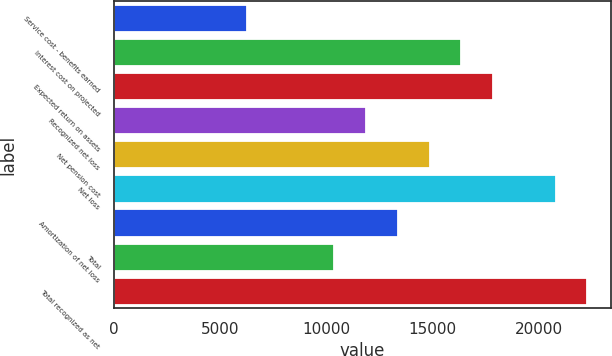<chart> <loc_0><loc_0><loc_500><loc_500><bar_chart><fcel>Service cost - benefits earned<fcel>Interest cost on projected<fcel>Expected return on assets<fcel>Recognized net loss<fcel>Net pension cost<fcel>Net loss<fcel>Amortization of net loss<fcel>Total<fcel>Total recognized as net<nl><fcel>6263<fcel>16364<fcel>17857.5<fcel>11883.5<fcel>14870.5<fcel>20805<fcel>13377<fcel>10390<fcel>22298.5<nl></chart> 